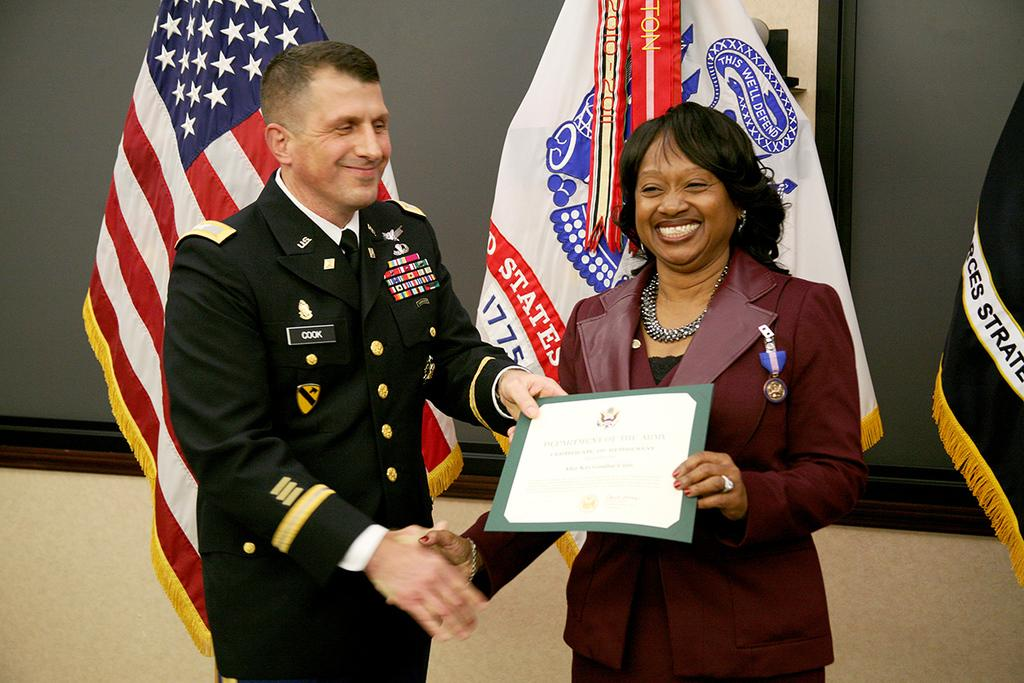Who is present in the image? There is a man and a woman in the image. What are the man and woman holding in the image? The man and woman are holding a certificate. What is the facial expression of the man and woman in the image? The man and woman are standing and smiling. What can be seen in the background of the image? There are flags and a window in the background of the image. Can you tell me how many people are enjoying a feast in the image? There is no feast present in the image; it features a man and a woman holding a certificate. What type of railway is visible in the image? There is no railway present in the image. 